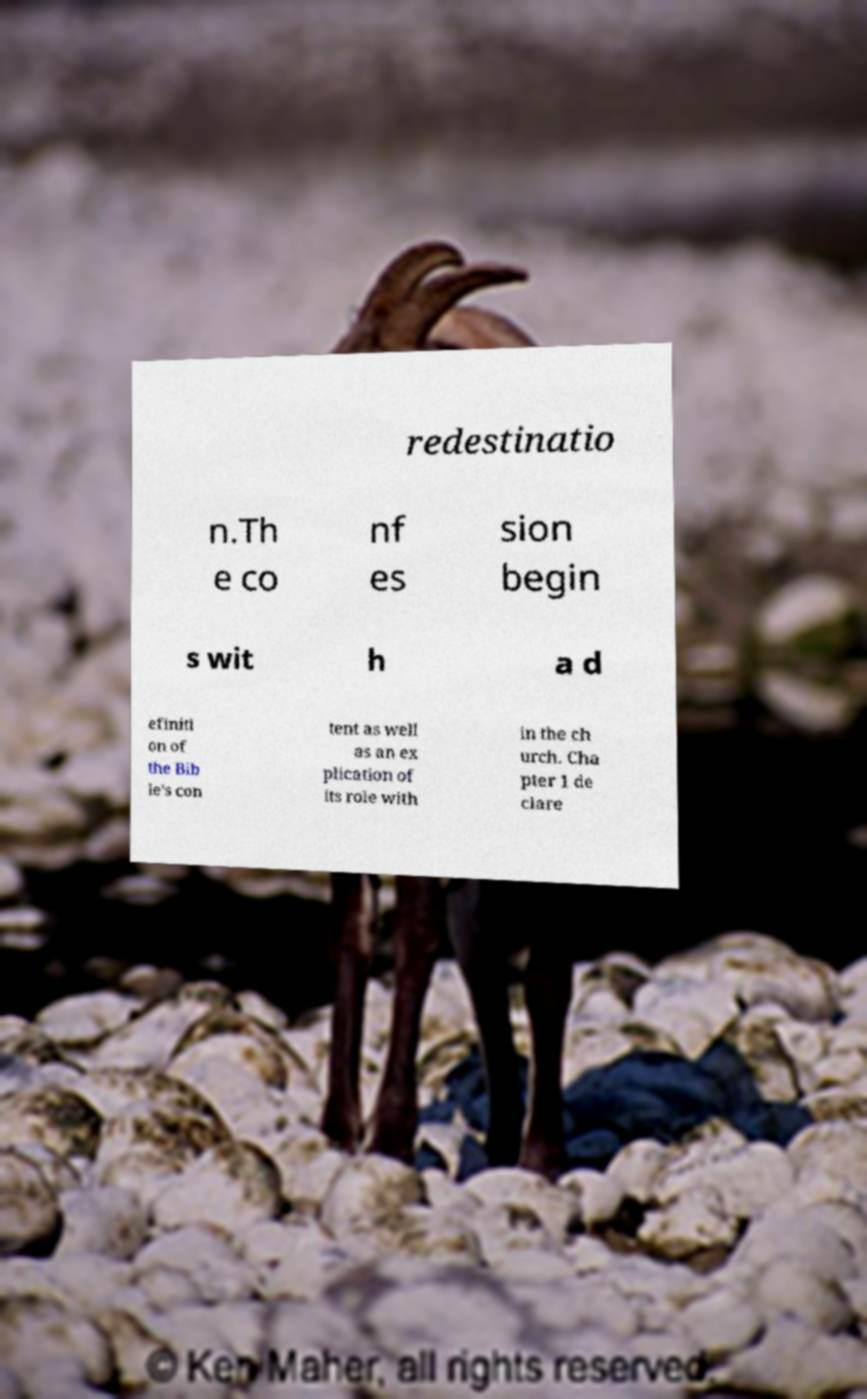Could you assist in decoding the text presented in this image and type it out clearly? redestinatio n.Th e co nf es sion begin s wit h a d efiniti on of the Bib le's con tent as well as an ex plication of its role with in the ch urch. Cha pter 1 de clare 